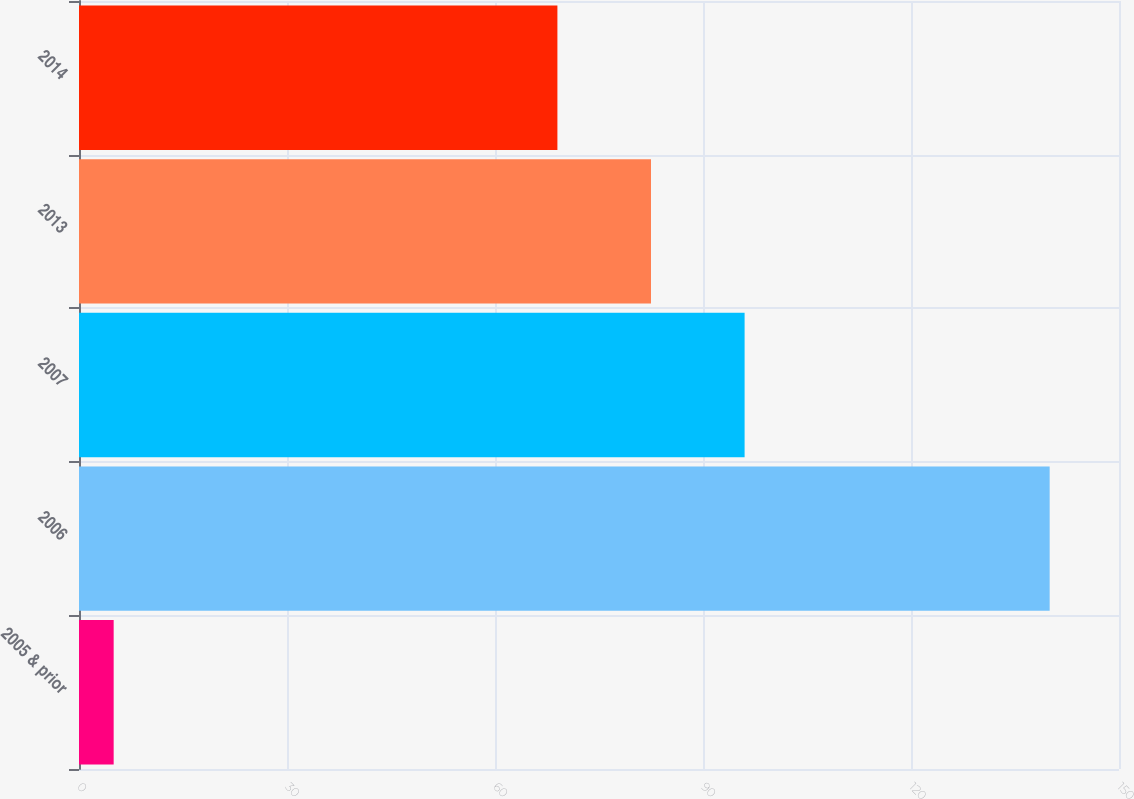<chart> <loc_0><loc_0><loc_500><loc_500><bar_chart><fcel>2005 & prior<fcel>2006<fcel>2007<fcel>2013<fcel>2014<nl><fcel>5<fcel>140<fcel>96<fcel>82.5<fcel>69<nl></chart> 